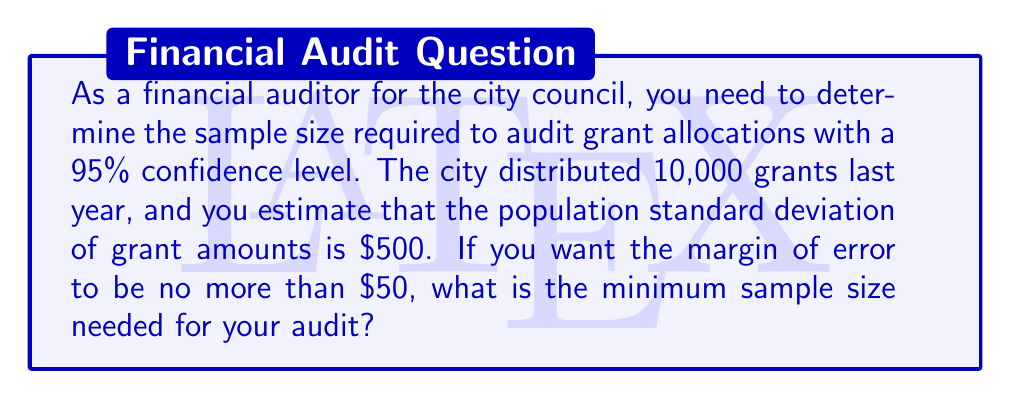Show me your answer to this math problem. To determine the sample size needed for a specified confidence level, we'll use the formula:

$$ n = \left(\frac{z_{\alpha/2} \cdot \sigma}{E}\right)^2 $$

Where:
- $n$ is the sample size
- $z_{\alpha/2}$ is the critical value for the desired confidence level
- $\sigma$ is the population standard deviation
- $E$ is the margin of error

Step 1: Identify the known values
- Confidence level: 95% (so $\alpha = 0.05$)
- Population standard deviation ($\sigma$): $500
- Margin of error ($E$): $50

Step 2: Find the critical value $z_{\alpha/2}$
For a 95% confidence level, $z_{\alpha/2} = 1.96$

Step 3: Plug the values into the formula
$$ n = \left(\frac{1.96 \cdot 500}{50}\right)^2 $$

Step 4: Calculate the result
$$ n = (1.96 \cdot 10)^2 = 19.6^2 = 384.16 $$

Step 5: Round up to the nearest whole number
Since we can't sample a fraction of a grant, we round up to 385.

Note: The population size (10,000) doesn't affect the calculation because it's large enough relative to the sample size. If the population were smaller, we might need to apply a finite population correction.
Answer: 385 grants 